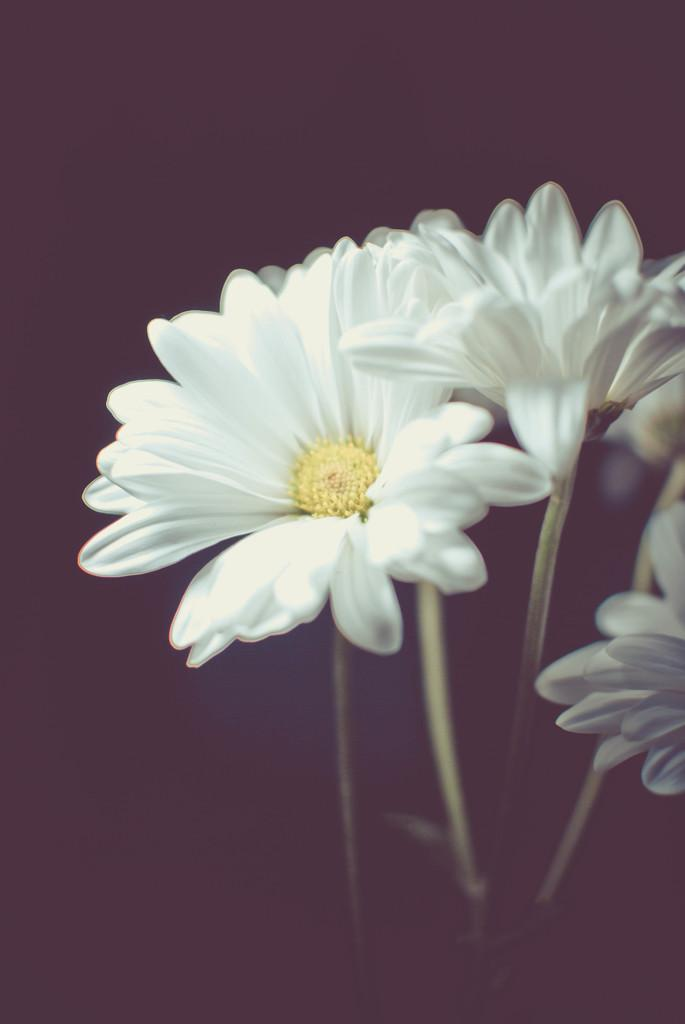What type of flora is present in the image? There are flowers in the image. Can you describe the colors of the flowers? The flowers are white and yellow in color. What is the color of the background in the image? The background of the image is black. What letters can be seen on the judge's robe in the image? There are no letters or judges present in the image; it features flowers with a black background. 